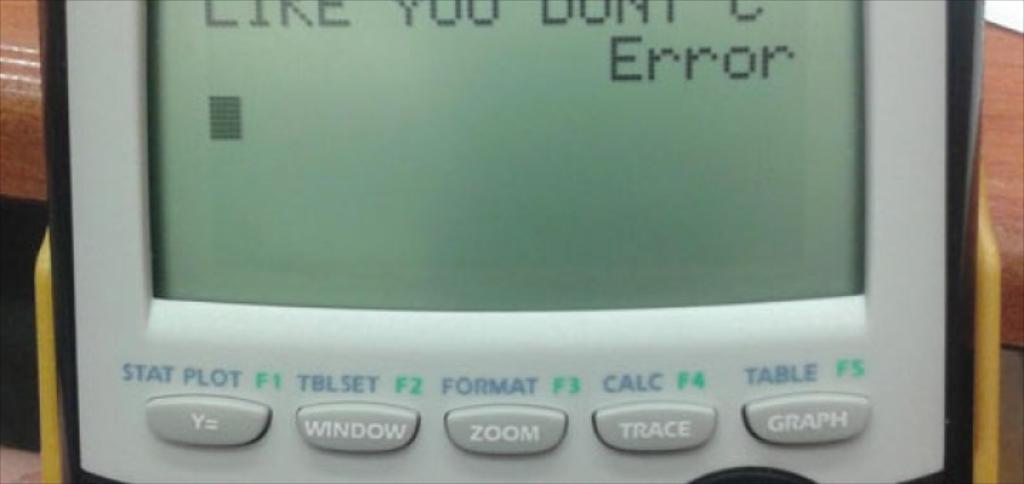<image>
Offer a succinct explanation of the picture presented. a screen shows in extreme close up the words ERROR 